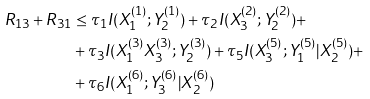Convert formula to latex. <formula><loc_0><loc_0><loc_500><loc_500>R _ { 1 3 } + R _ { 3 1 } & \leq \tau _ { 1 } I ( X _ { 1 } ^ { ( 1 ) } ; Y _ { 2 } ^ { ( 1 ) } ) + \tau _ { 2 } I ( X _ { 3 } ^ { ( 2 ) } ; Y _ { 2 } ^ { ( 2 ) } ) + \\ & + \tau _ { 3 } I ( X _ { 1 } ^ { ( 3 ) } X _ { 3 } ^ { ( 3 ) } ; Y _ { 2 } ^ { ( 3 ) } ) + \tau _ { 5 } I ( X _ { 3 } ^ { ( 5 ) } ; Y _ { 1 } ^ { ( 5 ) } | X _ { 2 } ^ { ( 5 ) } ) + \\ & + \tau _ { 6 } I ( X _ { 1 } ^ { ( 6 ) } ; Y _ { 3 } ^ { ( 6 ) } | X _ { 2 } ^ { ( 6 ) } )</formula> 